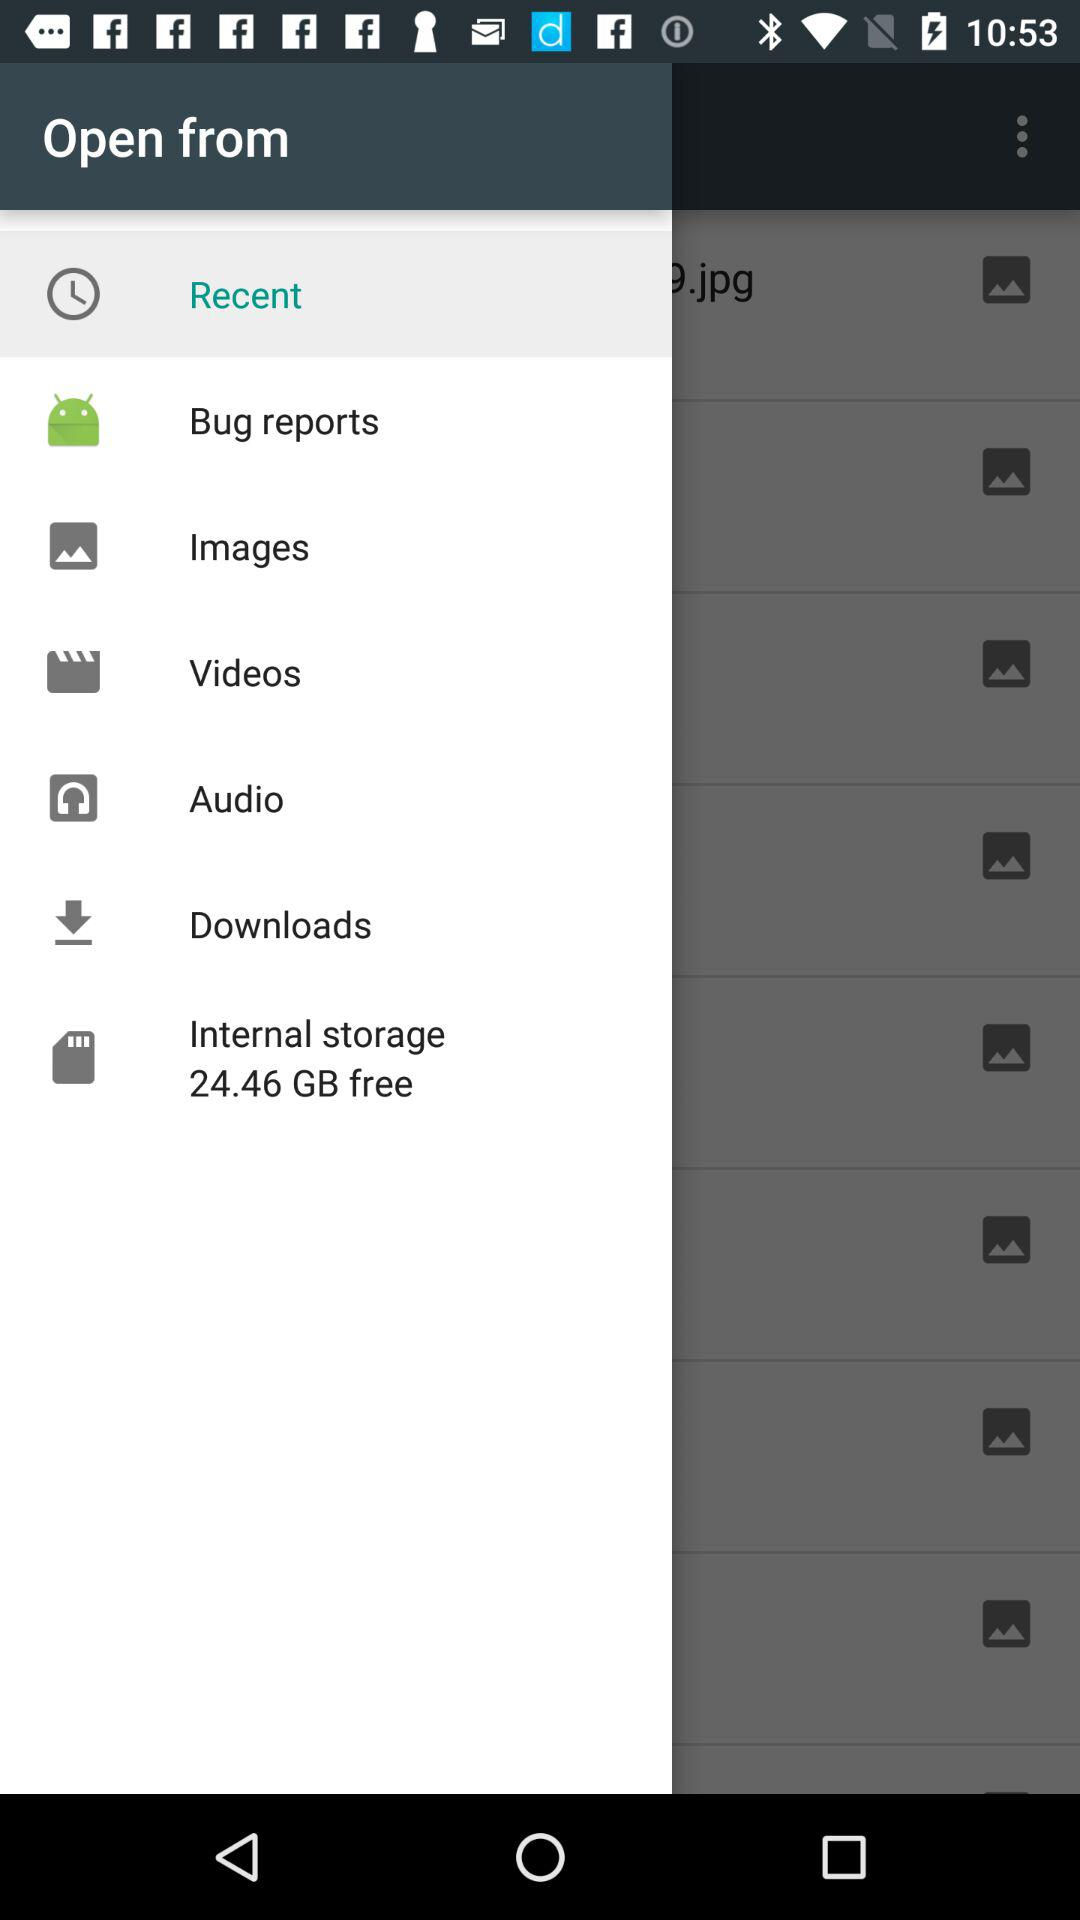How much space is available in internal storage? The available space in internal storage is 24.46 GB. 